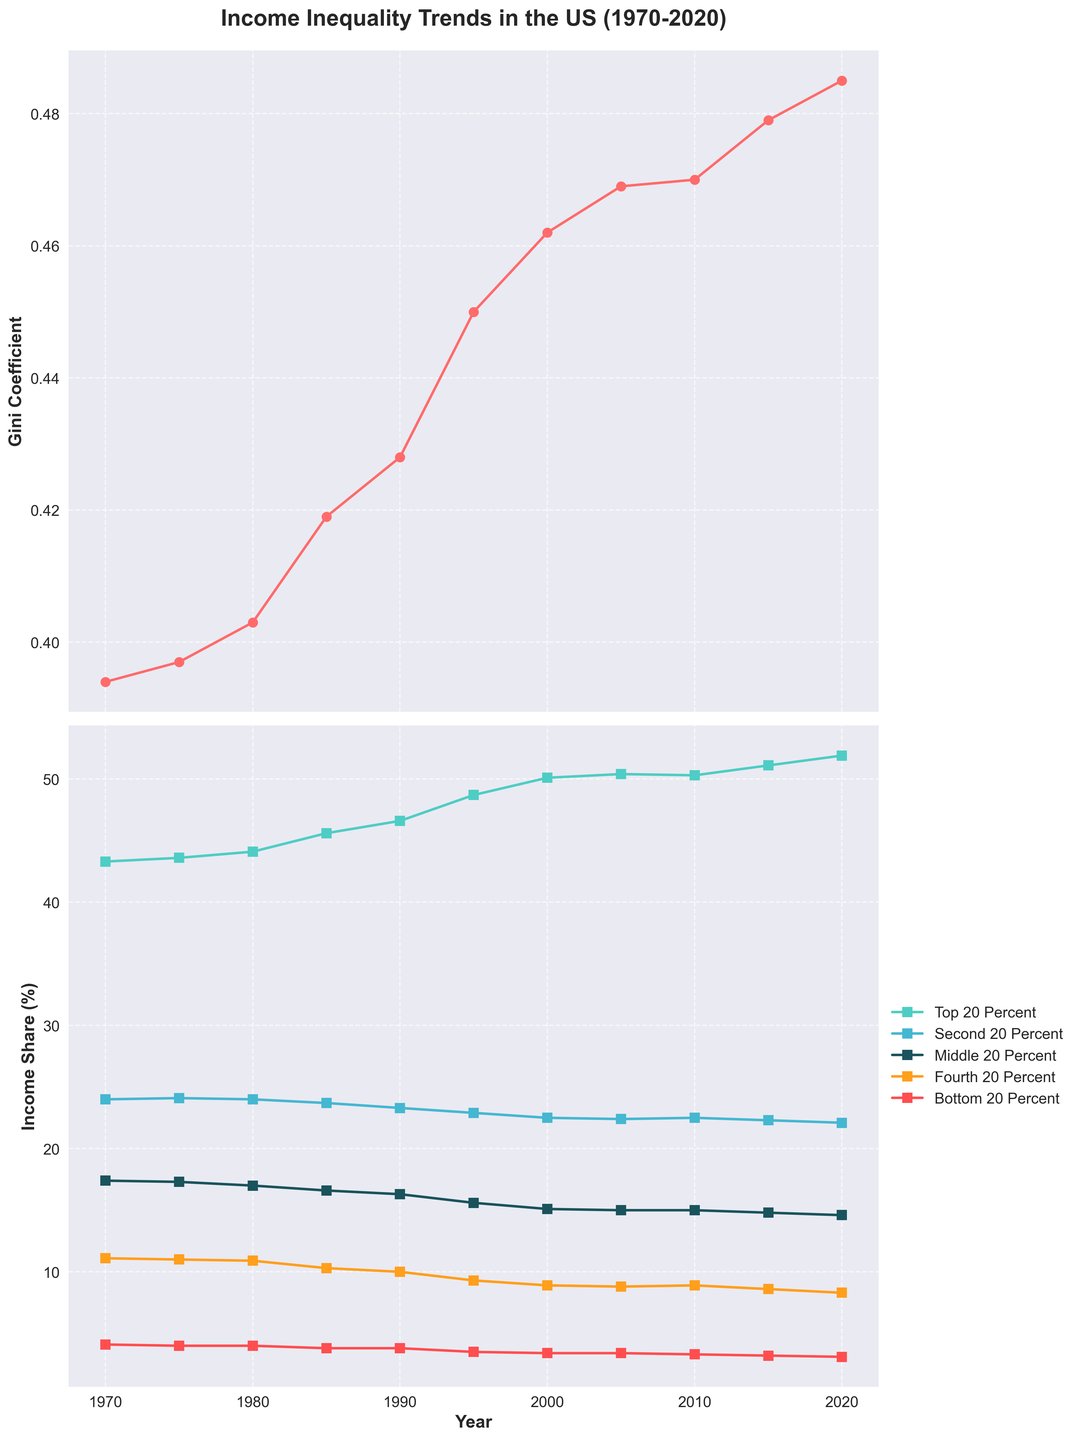Which year shows the highest Gini Coefficient? To find the year with the highest Gini Coefficient, look at the first subplot (the line graph). Identify the year where the red line peaks. The highest point on the red line is in the year 2020.
Answer: 2020 How does the income share of the bottom 20 percent in 2020 compare to 1970? Observe the second subplot. Locate the values of the Bottom 20 Percent (marked by a specific color) for the years 1970 and 2020. In 1970, the share is 4.1%, and in 2020, it is 3.1%. Therefore, the income share decreased by 1%.
Answer: Decreased by 1% What is the difference in income share between the top 20 percent and the bottom 20 percent in 1995? From the second subplot, find the values for the Top 20 Percent and Bottom 20 Percent in 1995. The Top 20 Percent is 48.7%, and the Bottom 20 Percent is 3.5%. The difference is 48.7% - 3.5% = 45.2%.
Answer: 45.2% Which quintile had the most stable income share over the 50-year period? Examine the second subplot to see how much each line (representing a quintile) fluctuates. The most stable line is the Second 20 Percent, as it shows the least variation from 1970 to 2020.
Answer: Second 20 Percent In which period did the Gini Coefficient show the most significant increase? Look at the first subplot for the steepest section of the red line. The major increase happened between 1980 and 1995. Therefore, the period between 1980 and 1995 shows the most significant rise.
Answer: 1980-1995 What is the total income share of the top 40 percent in 2000? Find the values for the Top 20 Percent and Second 20 Percent in 2000 from the second subplot. The Top 20 Percent is 50.1%, and the Second 20 Percent is 22.5%. The total income share is 50.1% + 22.5% = 72.6%.
Answer: 72.6% Does the income share of the middle 20 percent decrease or increase from 1980 to 2020? From the second subplot, find the Middle 20 Percent values for 1980 and 2020. In 1980, it is 17.0%, and in 2020, it is 14.6%. Therefore, the income share decreased.
Answer: Decrease By how many percentage points did the income share of the fourth 20 percent change from 1970 to 2020? Look at the second subplot for the Fourth 20 Percent values in 1970 and 2020. In 1970, it is 11.1%, and in 2020, it is 8.3%. The change is 11.1% - 8.3% = 2.8 percentage points.
Answer: 2.8 percentage points What is the average Gini Coefficient for the decades shown (calculate for the years 1970, 1980, 1990, 2000, 2010, and 2020)? Collect the Gini Coefficient values for the specified years: 1970 (0.394), 1980 (0.403), 1990 (0.428), 2000 (0.462), 2010 (0.470), and 2020 (0.485). The average is calculated as follows: (0.394 + 0.403 + 0.428 + 0.462 + 0.470 + 0.485) / 6 = 2.642 / 6 ≈ 0.440.
Answer: 0.440 